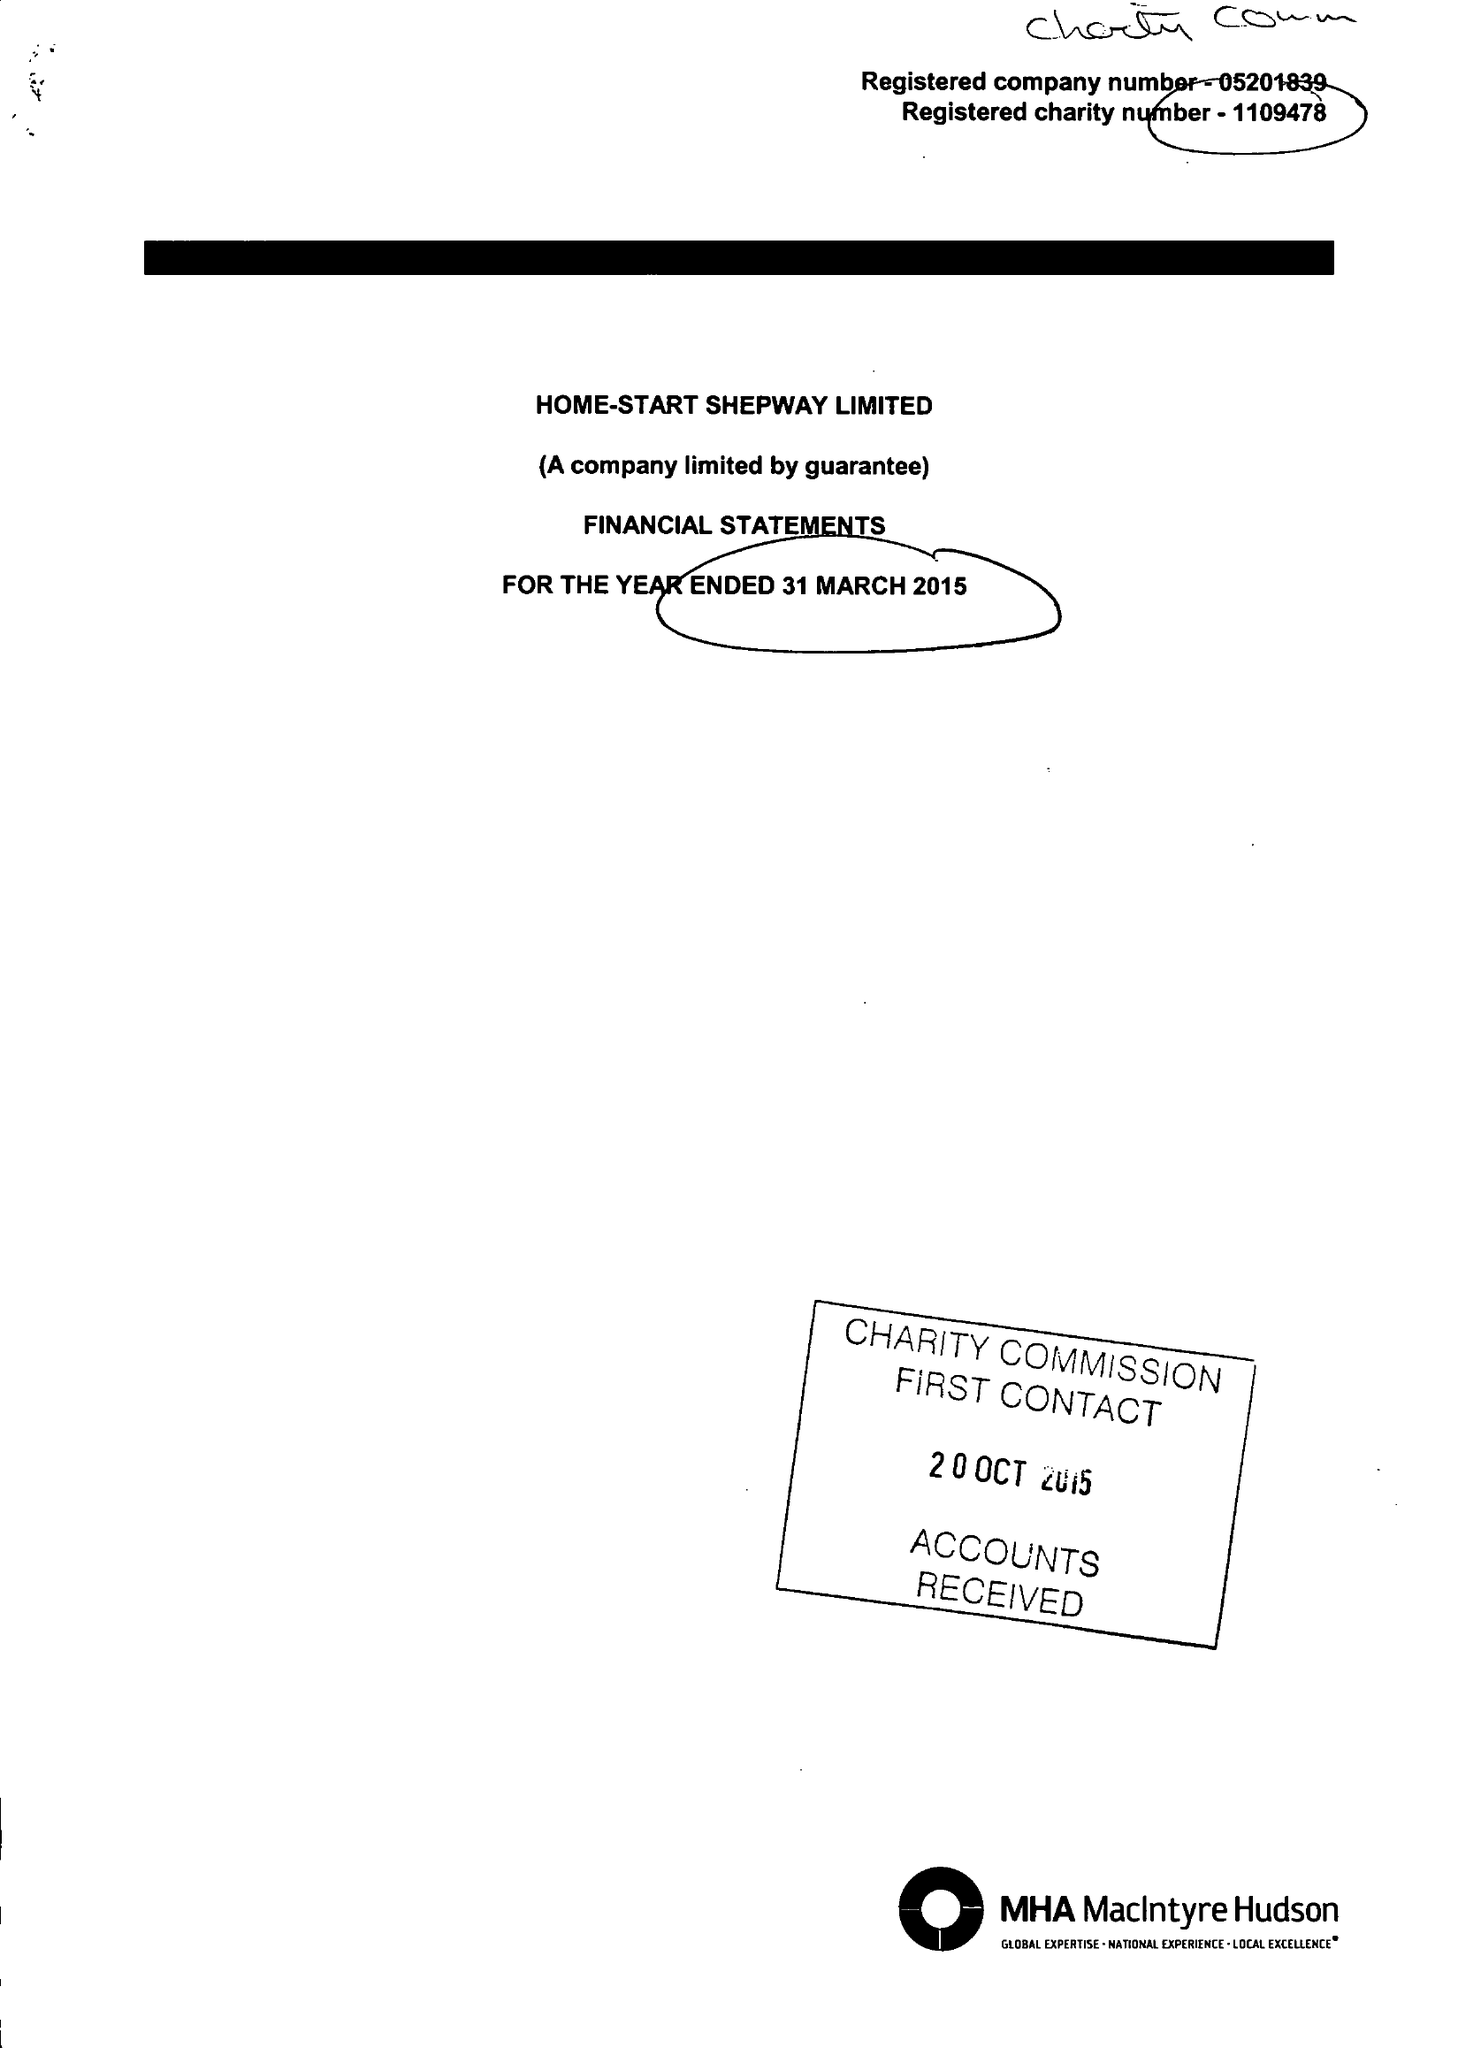What is the value for the report_date?
Answer the question using a single word or phrase. 2015-03-31 